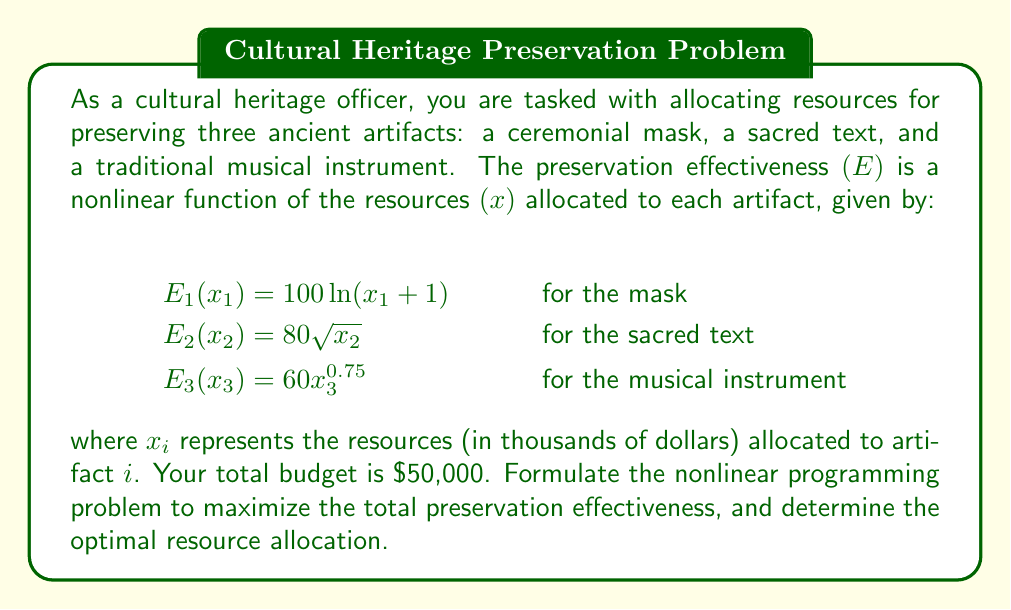What is the answer to this math problem? To solve this problem, we need to follow these steps:

1. Formulate the objective function:
The total preservation effectiveness is the sum of the individual effectiveness functions:
$$\text{Maximize } E = E_1(x_1) + E_2(x_2) + E_3(x_3)$$
$$E = 100\ln(x_1 + 1) + 80\sqrt{x_2} + 60x_3^{0.75}$$

2. Define the constraints:
The total budget constraint is:
$$x_1 + x_2 + x_3 \leq 50$$
And non-negativity constraints:
$$x_1, x_2, x_3 \geq 0$$

3. Set up the Lagrangian function:
$$L = 100\ln(x_1 + 1) + 80\sqrt{x_2} + 60x_3^{0.75} + \lambda(50 - x_1 - x_2 - x_3)$$

4. Apply the Karush-Kuhn-Tucker (KKT) conditions:
$$\frac{\partial L}{\partial x_1} = \frac{100}{x_1 + 1} - \lambda = 0$$
$$\frac{\partial L}{\partial x_2} = \frac{40}{\sqrt{x_2}} - \lambda = 0$$
$$\frac{\partial L}{\partial x_3} = 45x_3^{-0.25} - \lambda = 0$$
$$\frac{\partial L}{\partial \lambda} = 50 - x_1 - x_2 - x_3 = 0$$

5. Solve the system of equations:
From the first three equations:
$$x_1 = \frac{100}{\lambda} - 1$$
$$x_2 = \frac{1600}{\lambda^2}$$
$$x_3 = (\frac{45}{\lambda})^{4/3}$$

Substitute these into the budget constraint:
$$50 = (\frac{100}{\lambda} - 1) + \frac{1600}{\lambda^2} + (\frac{45}{\lambda})^{4/3}$$

This equation can be solved numerically to find $\lambda \approx 3.8815$.

6. Calculate the optimal resource allocation:
$$x_1 \approx 24.77$$
$$x_2 \approx 10.62$$
$$x_3 \approx 14.61$$

7. Verify the total budget:
$$24.77 + 10.62 + 14.61 = 50$$

The optimal resource allocation is approximately $24,770 for the mask, $10,620 for the sacred text, and $14,610 for the musical instrument.
Answer: Mask: $24,770; Sacred text: $10,620; Musical instrument: $14,610 